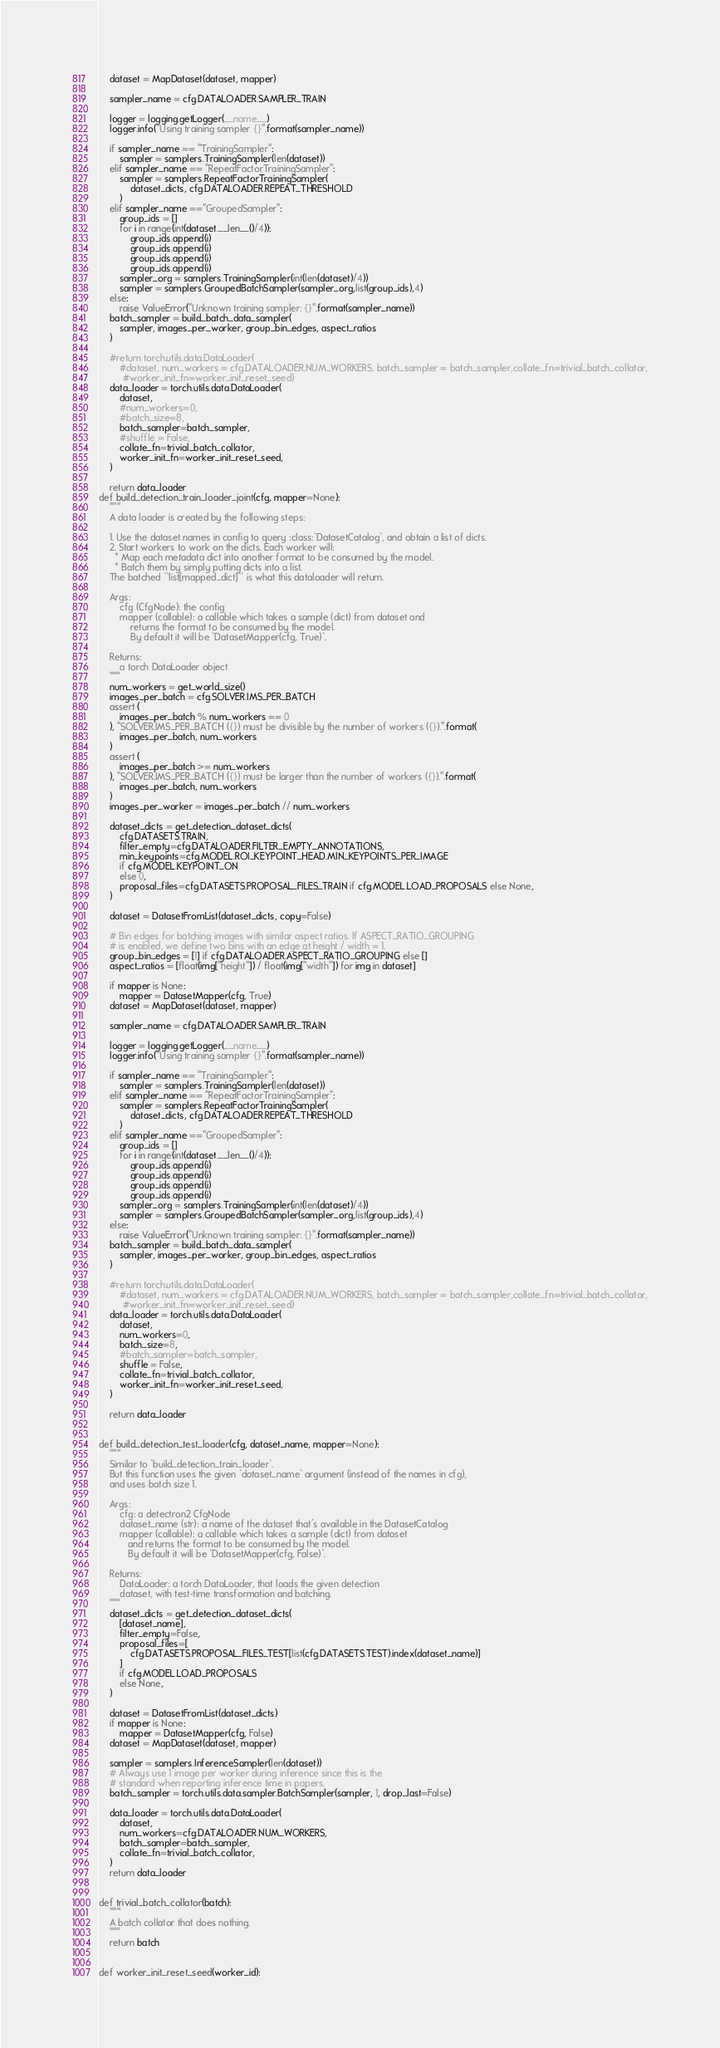Convert code to text. <code><loc_0><loc_0><loc_500><loc_500><_Python_>    dataset = MapDataset(dataset, mapper)
    
    sampler_name = cfg.DATALOADER.SAMPLER_TRAIN
    
    logger = logging.getLogger(__name__)
    logger.info("Using training sampler {}".format(sampler_name))
    
    if sampler_name == "TrainingSampler":
        sampler = samplers.TrainingSampler(len(dataset))
    elif sampler_name == "RepeatFactorTrainingSampler":
        sampler = samplers.RepeatFactorTrainingSampler(
            dataset_dicts, cfg.DATALOADER.REPEAT_THRESHOLD
        )
    elif sampler_name =="GroupedSampler":
        group_ids = []
        for i in range(int(dataset.__len__()/4)):
            group_ids.append(i)
            group_ids.append(i)
            group_ids.append(i)
            group_ids.append(i)
        sampler_org = samplers.TrainingSampler(int(len(dataset)/4))
        sampler = samplers.GroupedBatchSampler(sampler_org,list(group_ids),4)
    else:
        raise ValueError("Unknown training sampler: {}".format(sampler_name))
    batch_sampler = build_batch_data_sampler(
        sampler, images_per_worker, group_bin_edges, aspect_ratios
    )

    #return torch.utils.data.DataLoader(
        #dataset, num_workers = cfg.DATALOADER.NUM_WORKERS, batch_sampler = batch_sampler,collate_fn=trivial_batch_collator,
         #worker_init_fn=worker_init_reset_seed)
    data_loader = torch.utils.data.DataLoader(
        dataset,
        #num_workers=0,
        #batch_size=8,
        batch_sampler=batch_sampler,
        #shuffle = False,
        collate_fn=trivial_batch_collator,
        worker_init_fn=worker_init_reset_seed,
    )
   
    return data_loader
def build_detection_train_loader_joint(cfg, mapper=None):
    """
    A data loader is created by the following steps:

    1. Use the dataset names in config to query :class:`DatasetCatalog`, and obtain a list of dicts.
    2. Start workers to work on the dicts. Each worker will:
      * Map each metadata dict into another format to be consumed by the model.
      * Batch them by simply putting dicts into a list.
    The batched ``list[mapped_dict]`` is what this dataloader will return.

    Args:
        cfg (CfgNode): the config
        mapper (callable): a callable which takes a sample (dict) from dataset and
            returns the format to be consumed by the model.
            By default it will be `DatasetMapper(cfg, True)`.

    Returns:
        a torch DataLoader object
    """
    num_workers = get_world_size()
    images_per_batch = cfg.SOLVER.IMS_PER_BATCH
    assert (
        images_per_batch % num_workers == 0
    ), "SOLVER.IMS_PER_BATCH ({}) must be divisible by the number of workers ({}).".format(
        images_per_batch, num_workers
    )
    assert (
        images_per_batch >= num_workers
    ), "SOLVER.IMS_PER_BATCH ({}) must be larger than the number of workers ({}).".format(
        images_per_batch, num_workers
    )
    images_per_worker = images_per_batch // num_workers

    dataset_dicts = get_detection_dataset_dicts(
        cfg.DATASETS.TRAIN,
        filter_empty=cfg.DATALOADER.FILTER_EMPTY_ANNOTATIONS,
        min_keypoints=cfg.MODEL.ROI_KEYPOINT_HEAD.MIN_KEYPOINTS_PER_IMAGE
        if cfg.MODEL.KEYPOINT_ON
        else 0,
        proposal_files=cfg.DATASETS.PROPOSAL_FILES_TRAIN if cfg.MODEL.LOAD_PROPOSALS else None,
    )
    
    dataset = DatasetFromList(dataset_dicts, copy=False)
    
    # Bin edges for batching images with similar aspect ratios. If ASPECT_RATIO_GROUPING
    # is enabled, we define two bins with an edge at height / width = 1.
    group_bin_edges = [1] if cfg.DATALOADER.ASPECT_RATIO_GROUPING else []
    aspect_ratios = [float(img["height"]) / float(img["width"]) for img in dataset]

    if mapper is None:
        mapper = DatasetMapper(cfg, True)
    dataset = MapDataset(dataset, mapper)
    
    sampler_name = cfg.DATALOADER.SAMPLER_TRAIN
    
    logger = logging.getLogger(__name__)
    logger.info("Using training sampler {}".format(sampler_name))
    
    if sampler_name == "TrainingSampler":
        sampler = samplers.TrainingSampler(len(dataset))
    elif sampler_name == "RepeatFactorTrainingSampler":
        sampler = samplers.RepeatFactorTrainingSampler(
            dataset_dicts, cfg.DATALOADER.REPEAT_THRESHOLD
        )
    elif sampler_name =="GroupedSampler":
        group_ids = []
        for i in range(int(dataset.__len__()/4)):
            group_ids.append(i)
            group_ids.append(i)
            group_ids.append(i)
            group_ids.append(i)
        sampler_org = samplers.TrainingSampler(int(len(dataset)/4))
        sampler = samplers.GroupedBatchSampler(sampler_org,list(group_ids),4)
    else:
        raise ValueError("Unknown training sampler: {}".format(sampler_name))
    batch_sampler = build_batch_data_sampler(
        sampler, images_per_worker, group_bin_edges, aspect_ratios
    )

    #return torch.utils.data.DataLoader(
        #dataset, num_workers = cfg.DATALOADER.NUM_WORKERS, batch_sampler = batch_sampler,collate_fn=trivial_batch_collator,
         #worker_init_fn=worker_init_reset_seed)
    data_loader = torch.utils.data.DataLoader(
        dataset,
        num_workers=0,
        batch_size=8,
        #batch_sampler=batch_sampler,
        shuffle = False,
        collate_fn=trivial_batch_collator,
        worker_init_fn=worker_init_reset_seed,
    )
   
    return data_loader


def build_detection_test_loader(cfg, dataset_name, mapper=None):
    """
    Similar to `build_detection_train_loader`.
    But this function uses the given `dataset_name` argument (instead of the names in cfg),
    and uses batch size 1.

    Args:
        cfg: a detectron2 CfgNode
        dataset_name (str): a name of the dataset that's available in the DatasetCatalog
        mapper (callable): a callable which takes a sample (dict) from dataset
           and returns the format to be consumed by the model.
           By default it will be `DatasetMapper(cfg, False)`.

    Returns:
        DataLoader: a torch DataLoader, that loads the given detection
        dataset, with test-time transformation and batching.
    """
    dataset_dicts = get_detection_dataset_dicts(
        [dataset_name],
        filter_empty=False,
        proposal_files=[
            cfg.DATASETS.PROPOSAL_FILES_TEST[list(cfg.DATASETS.TEST).index(dataset_name)]
        ]
        if cfg.MODEL.LOAD_PROPOSALS
        else None,
    )

    dataset = DatasetFromList(dataset_dicts)
    if mapper is None:
        mapper = DatasetMapper(cfg, False)
    dataset = MapDataset(dataset, mapper)

    sampler = samplers.InferenceSampler(len(dataset))
    # Always use 1 image per worker during inference since this is the
    # standard when reporting inference time in papers.
    batch_sampler = torch.utils.data.sampler.BatchSampler(sampler, 1, drop_last=False)

    data_loader = torch.utils.data.DataLoader(
        dataset,
        num_workers=cfg.DATALOADER.NUM_WORKERS,
        batch_sampler=batch_sampler,
        collate_fn=trivial_batch_collator,
    )
    return data_loader


def trivial_batch_collator(batch):
    """
    A batch collator that does nothing.
    """
    return batch


def worker_init_reset_seed(worker_id):</code> 